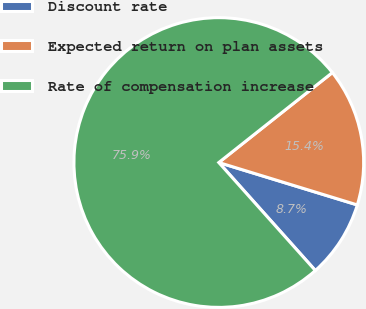<chart> <loc_0><loc_0><loc_500><loc_500><pie_chart><fcel>Discount rate<fcel>Expected return on plan assets<fcel>Rate of compensation increase<nl><fcel>8.66%<fcel>15.39%<fcel>75.95%<nl></chart> 